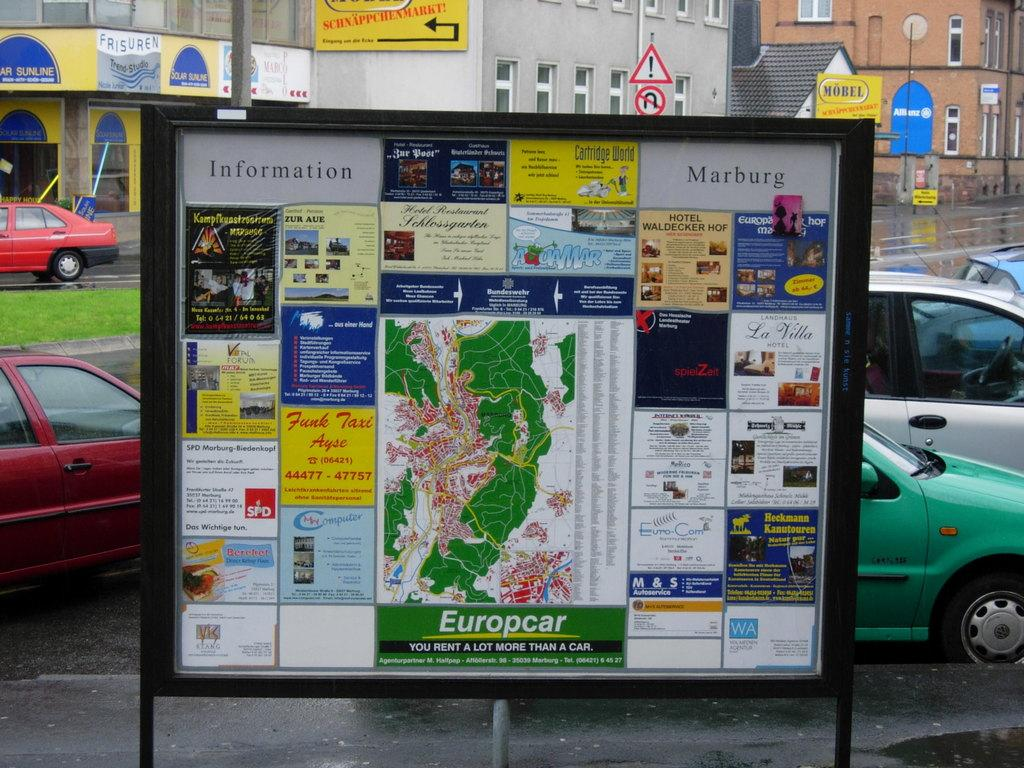<image>
Write a terse but informative summary of the picture. A map, labelled Europcar, shows information about renting a car. 